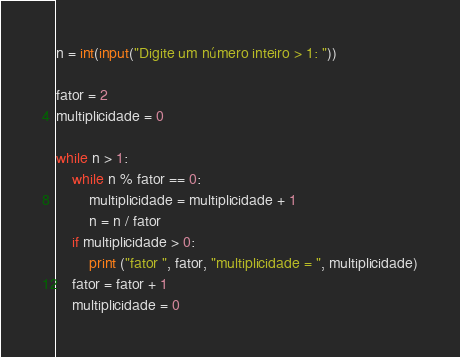<code> <loc_0><loc_0><loc_500><loc_500><_Python_>n = int(input("Digite um número inteiro > 1: "))

fator = 2
multiplicidade = 0

while n > 1:
    while n % fator == 0:
        multiplicidade = multiplicidade + 1
        n = n / fator
    if multiplicidade > 0:
        print ("fator ", fator, "multiplicidade = ", multiplicidade)
    fator = fator + 1
    multiplicidade = 0
</code> 